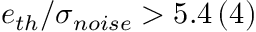Convert formula to latex. <formula><loc_0><loc_0><loc_500><loc_500>e _ { t h } / \sigma _ { n o i s e } > 5 . 4 \, ( 4 )</formula> 